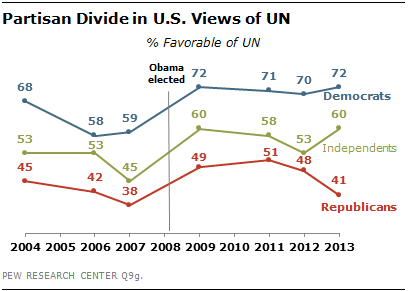Draw attention to some important aspects in this diagram. A line whose values are always greater than those of the other two is considered blue. The median values of the three lines from 2011 to 2013 were added. 